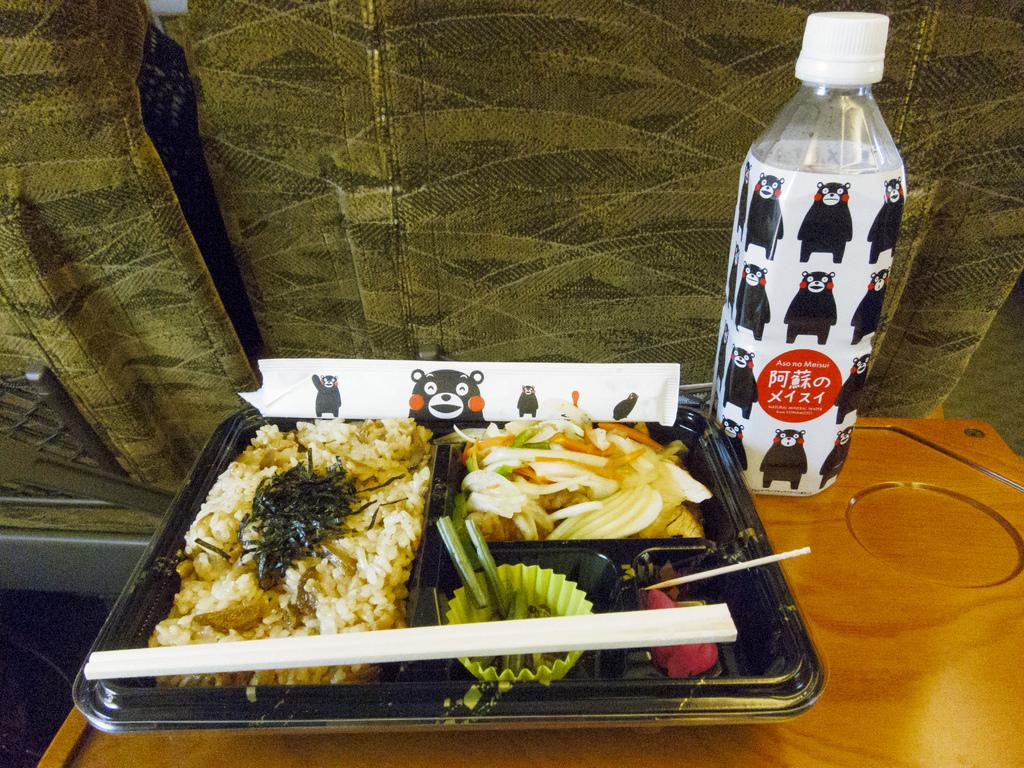<image>
Render a clear and concise summary of the photo. Tray of food next to a bottle with a red sign that says "Aso no meisui". 